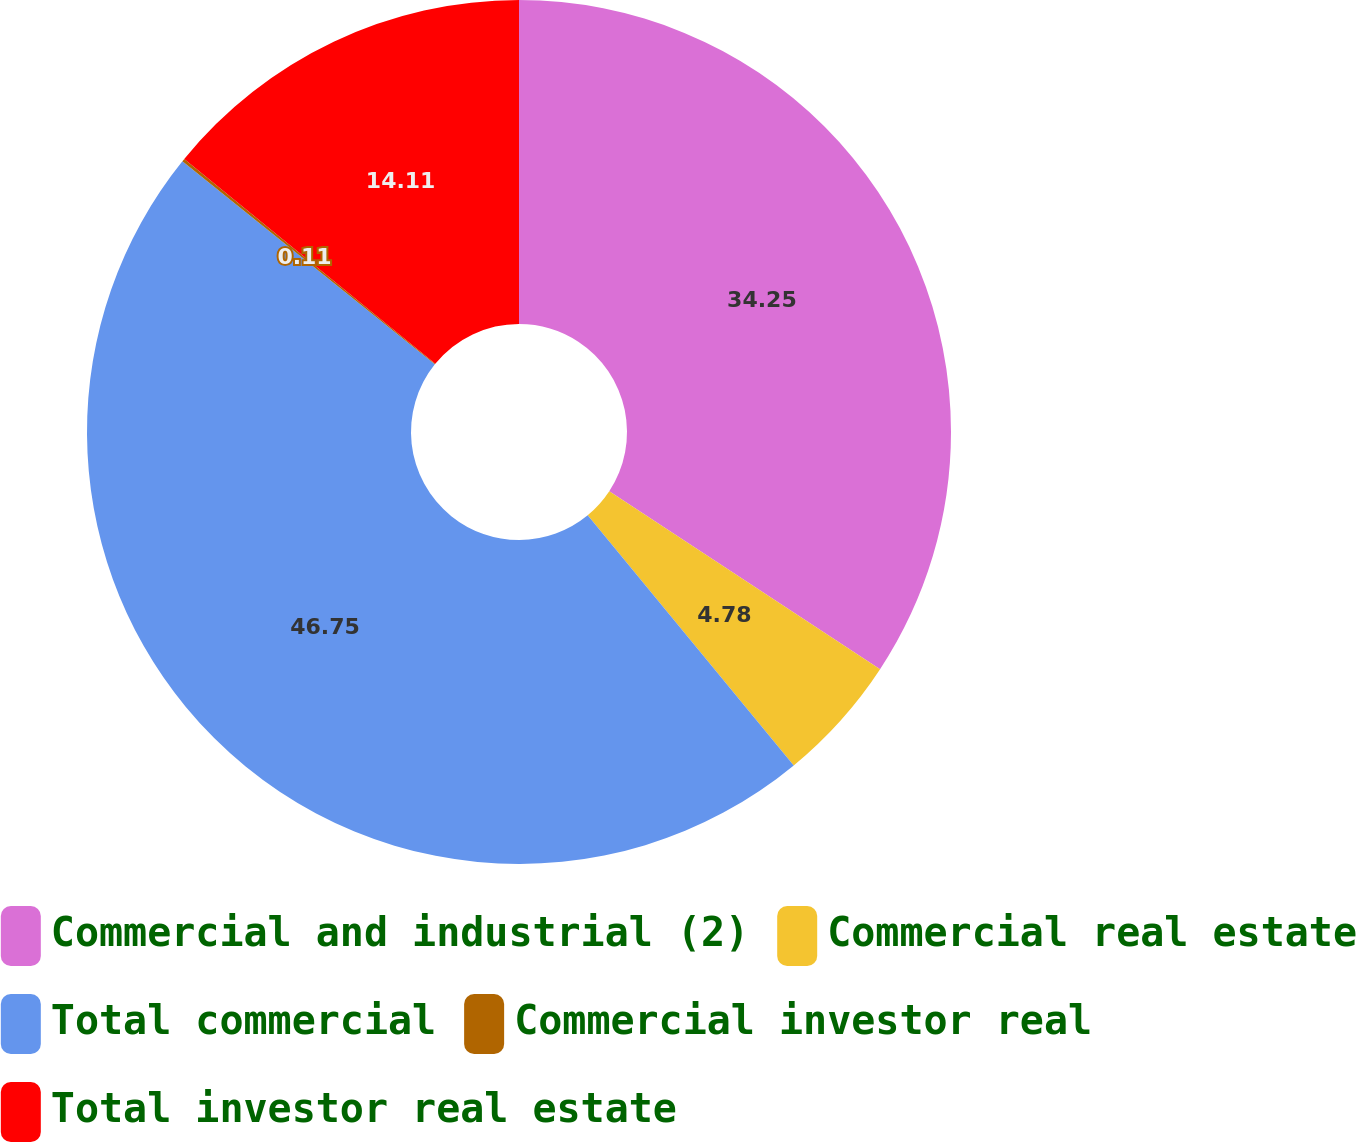Convert chart to OTSL. <chart><loc_0><loc_0><loc_500><loc_500><pie_chart><fcel>Commercial and industrial (2)<fcel>Commercial real estate<fcel>Total commercial<fcel>Commercial investor real<fcel>Total investor real estate<nl><fcel>34.25%<fcel>4.78%<fcel>46.75%<fcel>0.11%<fcel>14.11%<nl></chart> 